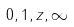<formula> <loc_0><loc_0><loc_500><loc_500>0 , 1 , z , \infty</formula> 